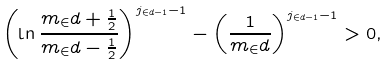<formula> <loc_0><loc_0><loc_500><loc_500>\left ( \ln \frac { m _ { \in } d + \frac { 1 } { 2 } } { m _ { \in } d - \frac { 1 } { 2 } } \right ) ^ { j _ { \in d - 1 } - 1 } - \left ( \frac { 1 } { m _ { \in } d } \right ) ^ { j _ { \in d - 1 } - 1 } > 0 ,</formula> 